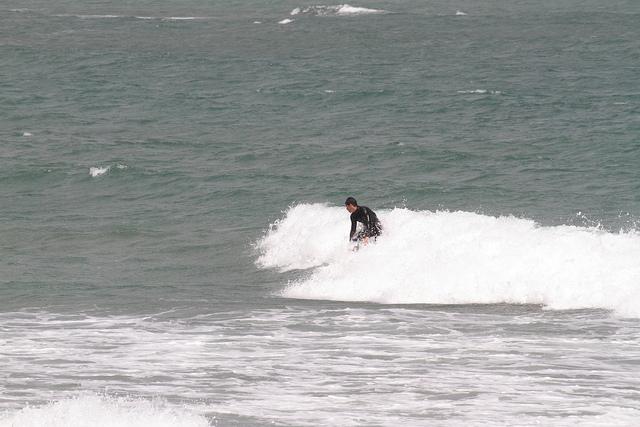Is this man skiing?
Short answer required. No. Are the waves high?
Short answer required. No. What is the weather like?
Write a very short answer. Sunny. What is this person riding?
Answer briefly. Surfboard. How many people are in the water?
Keep it brief. 1. 